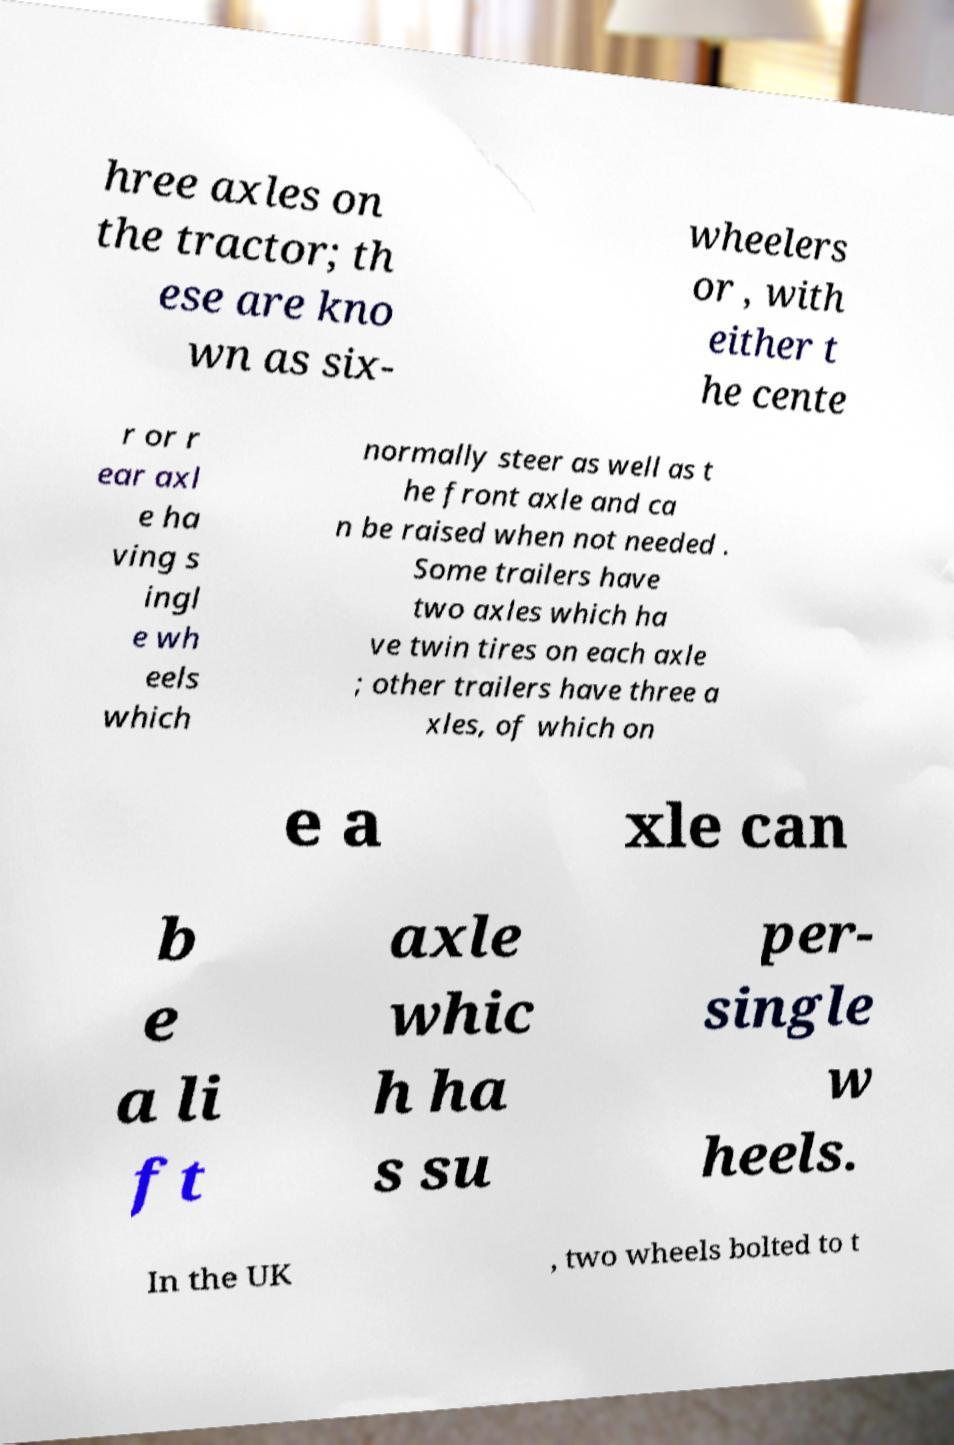What messages or text are displayed in this image? I need them in a readable, typed format. hree axles on the tractor; th ese are kno wn as six- wheelers or , with either t he cente r or r ear axl e ha ving s ingl e wh eels which normally steer as well as t he front axle and ca n be raised when not needed . Some trailers have two axles which ha ve twin tires on each axle ; other trailers have three a xles, of which on e a xle can b e a li ft axle whic h ha s su per- single w heels. In the UK , two wheels bolted to t 